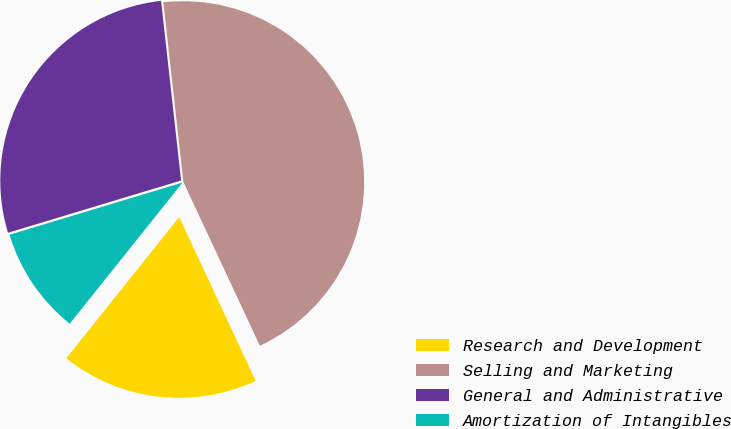Convert chart. <chart><loc_0><loc_0><loc_500><loc_500><pie_chart><fcel>Research and Development<fcel>Selling and Marketing<fcel>General and Administrative<fcel>Amortization of Intangibles<nl><fcel>17.69%<fcel>44.81%<fcel>27.9%<fcel>9.6%<nl></chart> 